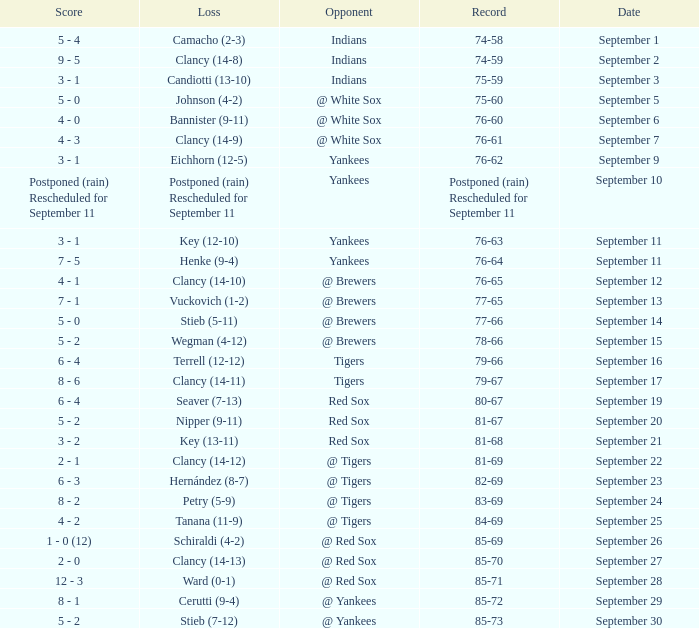What was the date of the game when their record was 84-69? September 25. 